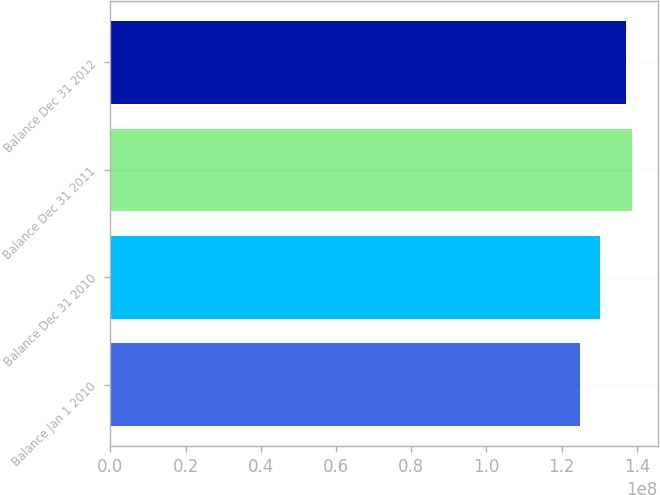Convert chart. <chart><loc_0><loc_0><loc_500><loc_500><bar_chart><fcel>Balance Jan 1 2010<fcel>Balance Dec 31 2010<fcel>Balance Dec 31 2011<fcel>Balance Dec 31 2012<nl><fcel>1.24905e+08<fcel>1.30191e+08<fcel>1.38684e+08<fcel>1.37007e+08<nl></chart> 